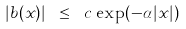<formula> <loc_0><loc_0><loc_500><loc_500>| b ( x ) | \ \leq \ c \, \exp ( - \alpha | x | )</formula> 